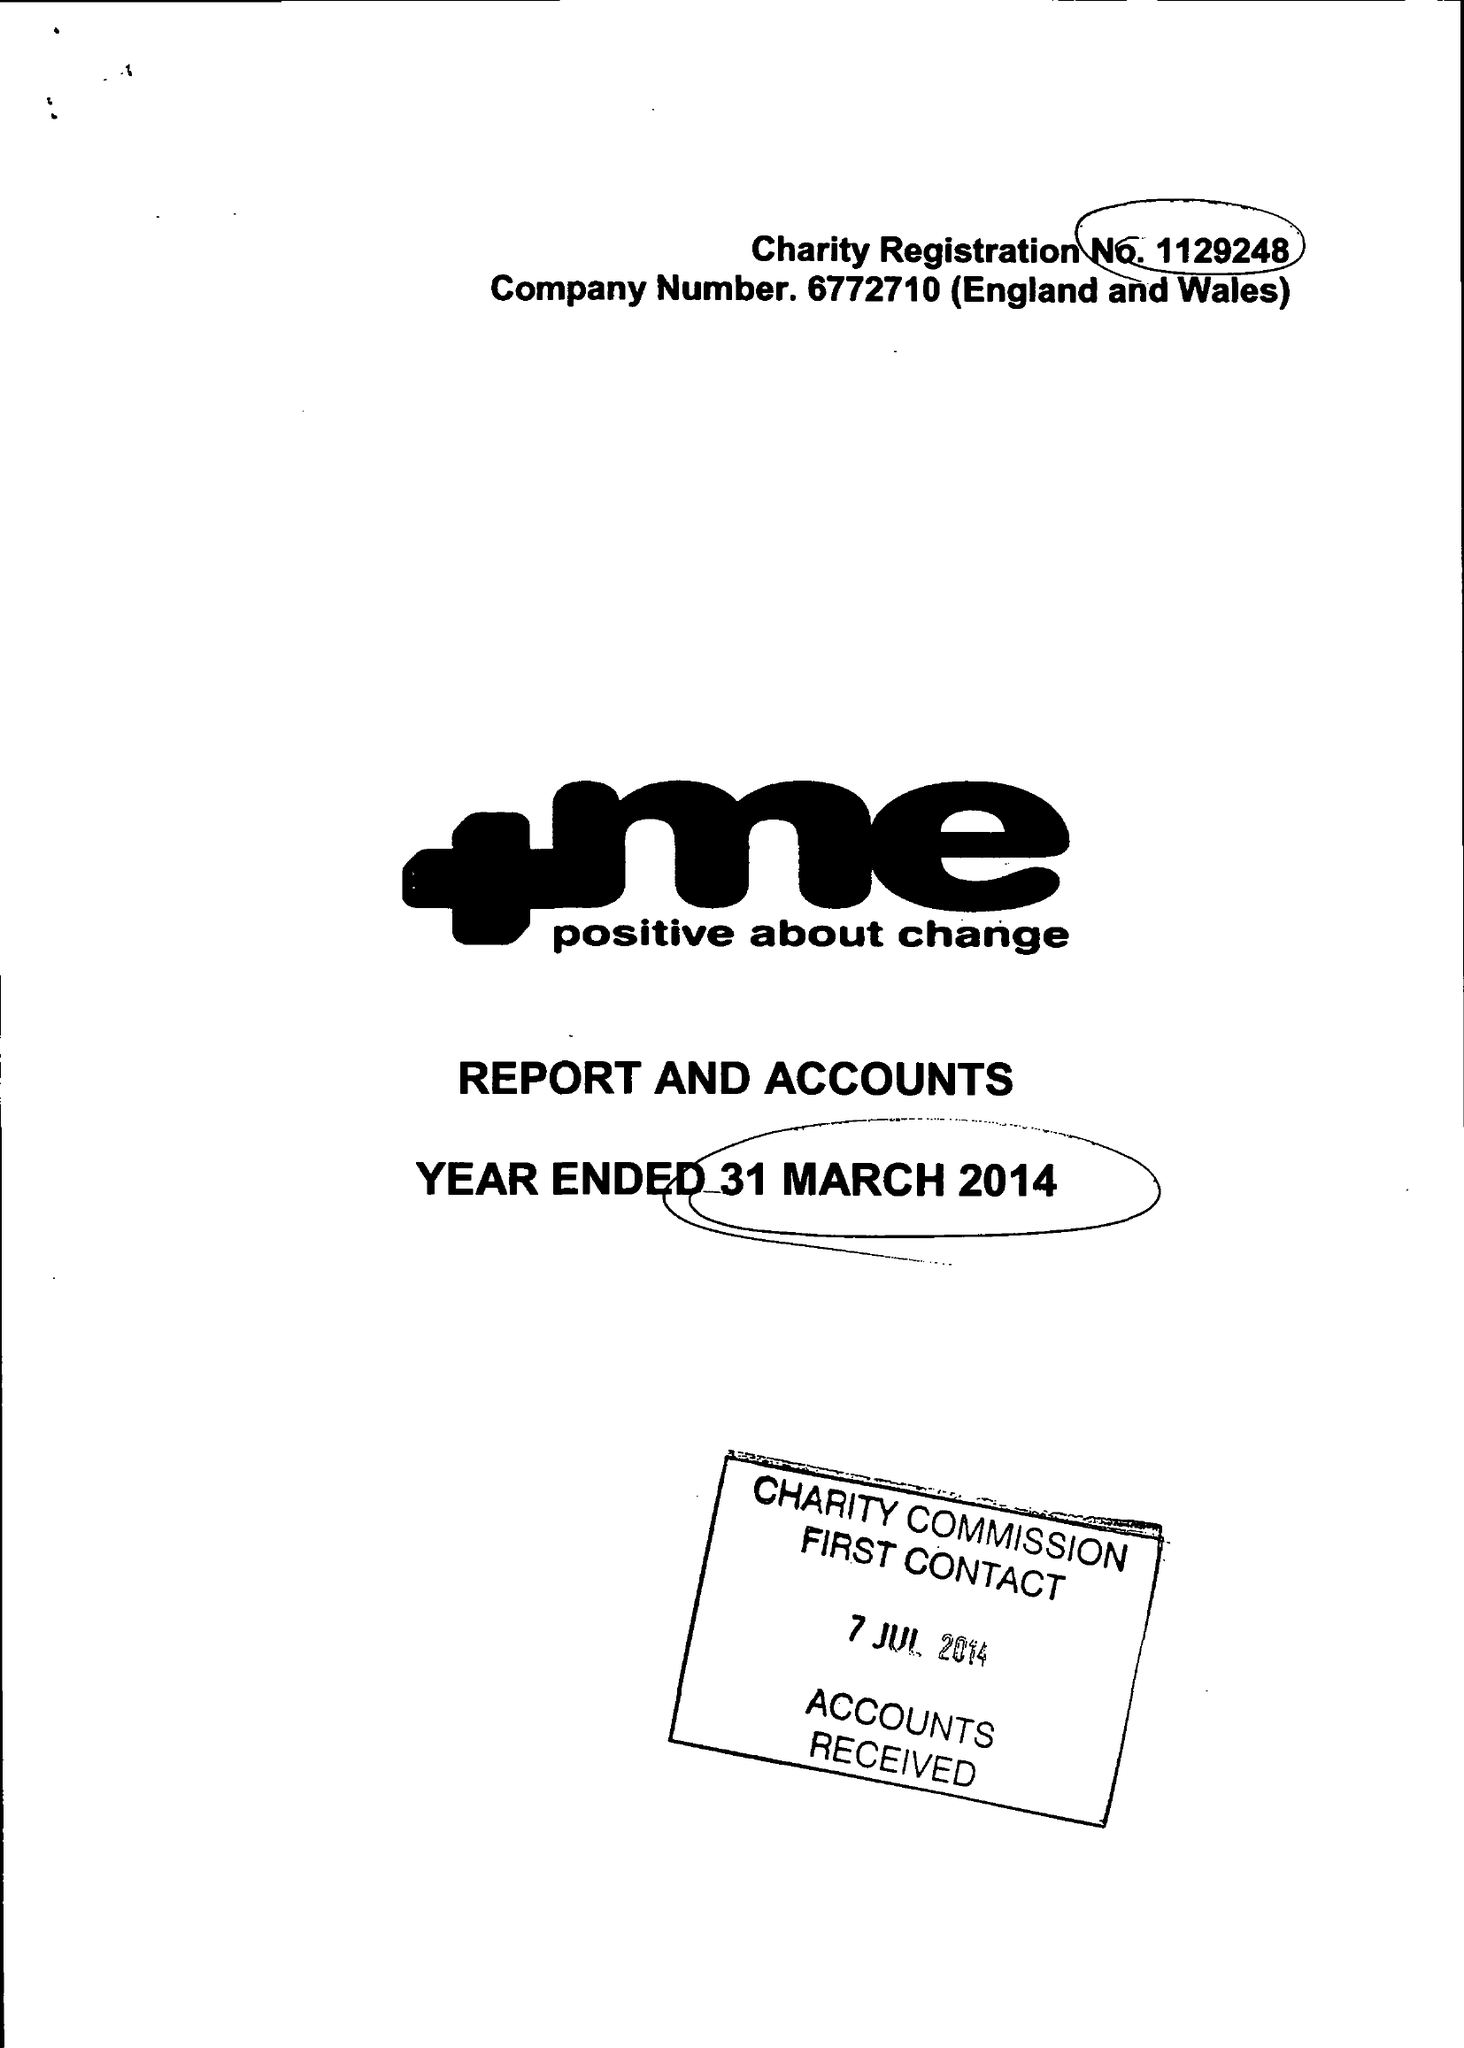What is the value for the income_annually_in_british_pounds?
Answer the question using a single word or phrase. 108075.00 